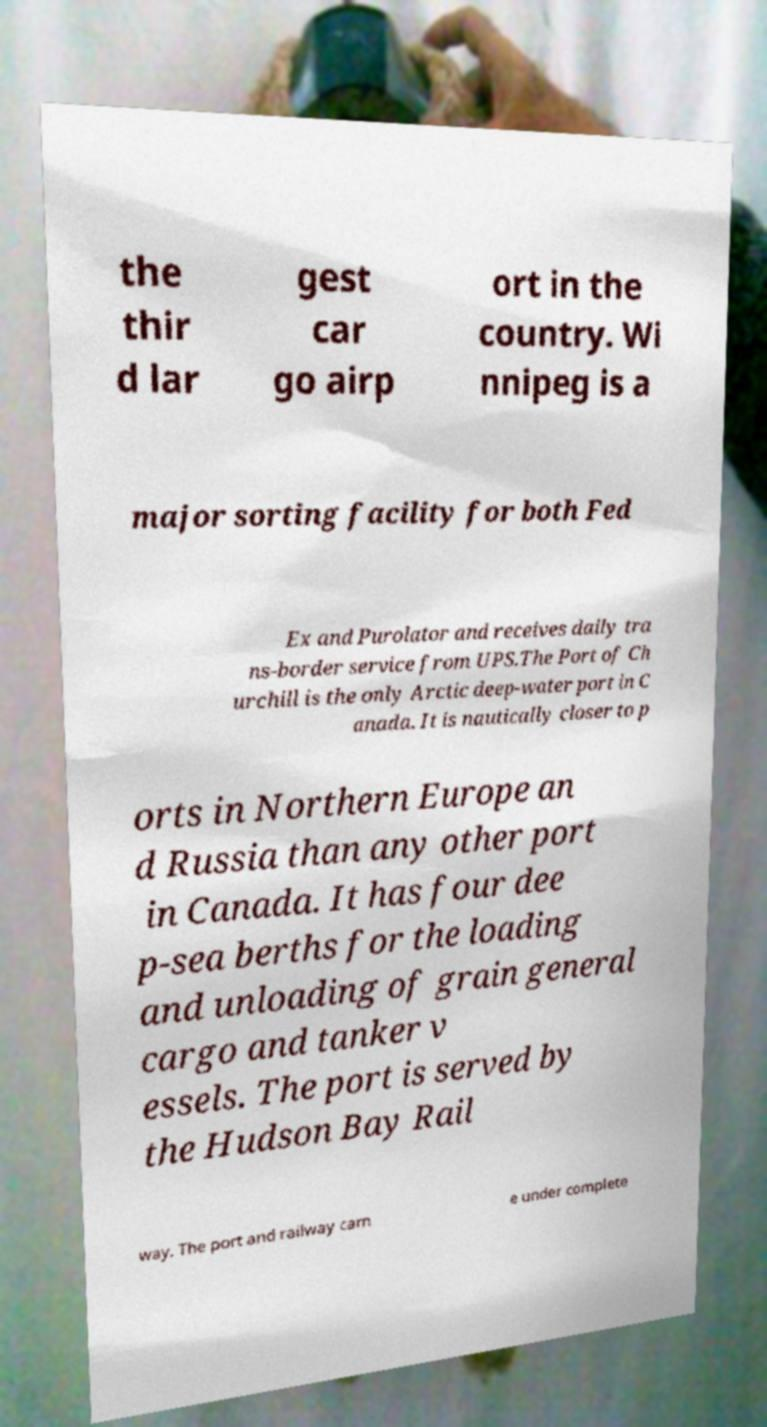Could you extract and type out the text from this image? the thir d lar gest car go airp ort in the country. Wi nnipeg is a major sorting facility for both Fed Ex and Purolator and receives daily tra ns-border service from UPS.The Port of Ch urchill is the only Arctic deep-water port in C anada. It is nautically closer to p orts in Northern Europe an d Russia than any other port in Canada. It has four dee p-sea berths for the loading and unloading of grain general cargo and tanker v essels. The port is served by the Hudson Bay Rail way. The port and railway cam e under complete 